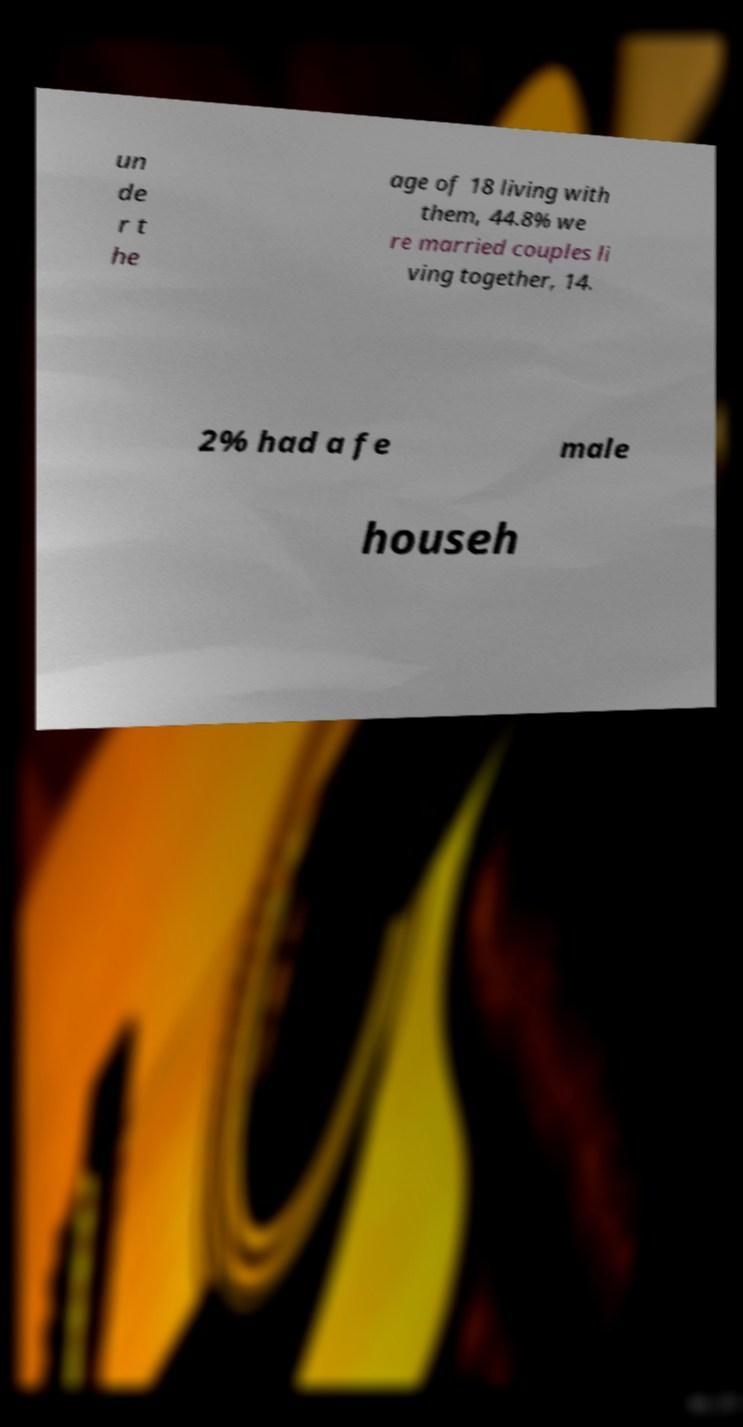Can you read and provide the text displayed in the image?This photo seems to have some interesting text. Can you extract and type it out for me? un de r t he age of 18 living with them, 44.8% we re married couples li ving together, 14. 2% had a fe male househ 